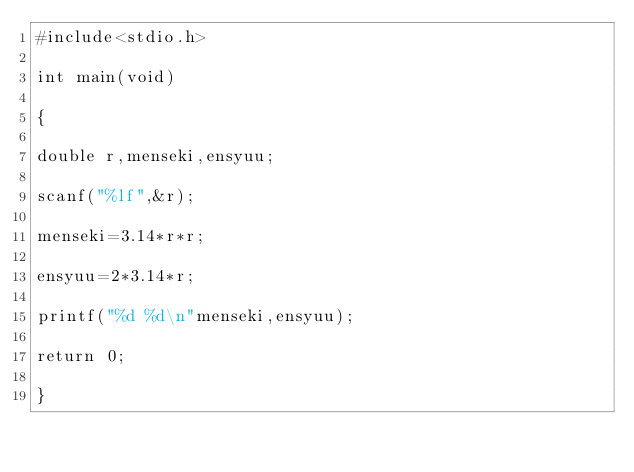<code> <loc_0><loc_0><loc_500><loc_500><_C_>#include<stdio.h>

int main(void)

{

double r,menseki,ensyuu;

scanf("%lf",&r);

menseki=3.14*r*r;

ensyuu=2*3.14*r;

printf("%d %d\n"menseki,ensyuu);

return 0;

}</code> 